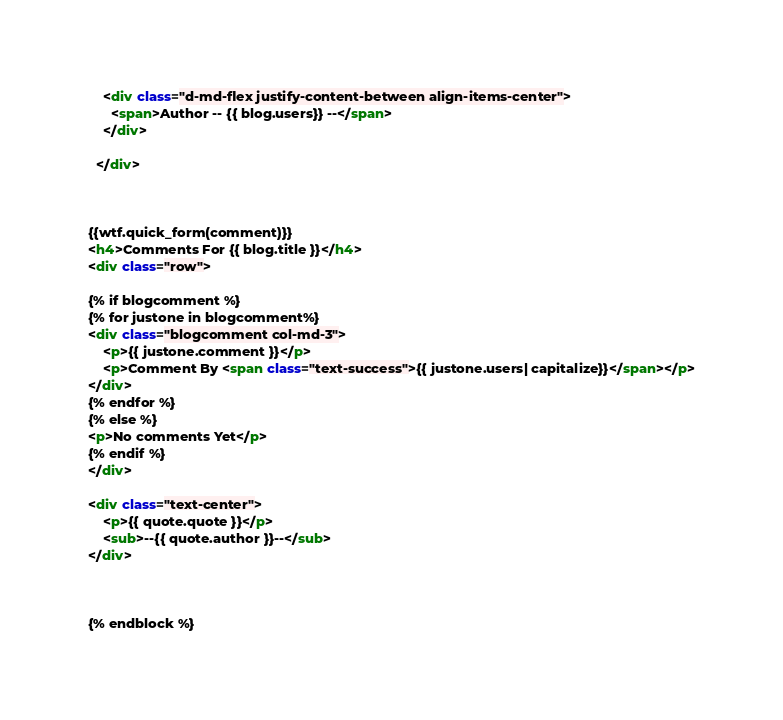Convert code to text. <code><loc_0><loc_0><loc_500><loc_500><_HTML_>    <div class="d-md-flex justify-content-between align-items-center">
      <span>Author -- {{ blog.users}} --</span>
    </div>

  </div>



{{wtf.quick_form(comment)}}
<h4>Comments For {{ blog.title }}</h4>
<div class="row">

{% if blogcomment %}
{% for justone in blogcomment%}
<div class="blogcomment col-md-3">
    <p>{{ justone.comment }}</p>
    <p>Comment By <span class="text-success">{{ justone.users| capitalize}}</span></p>
</div>
{% endfor %}
{% else %}
<p>No comments Yet</p>
{% endif %}
</div>

<div class="text-center">
    <p>{{ quote.quote }}</p>
    <sub>--{{ quote.author }}--</sub>
</div>



{% endblock %}</code> 